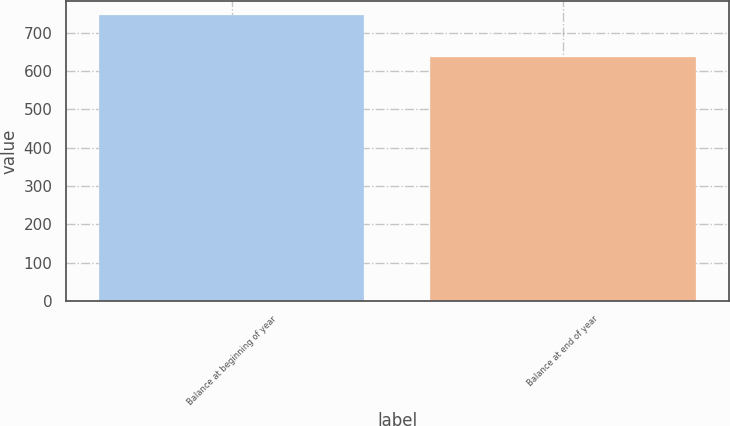Convert chart. <chart><loc_0><loc_0><loc_500><loc_500><bar_chart><fcel>Balance at beginning of year<fcel>Balance at end of year<nl><fcel>746<fcel>638<nl></chart> 